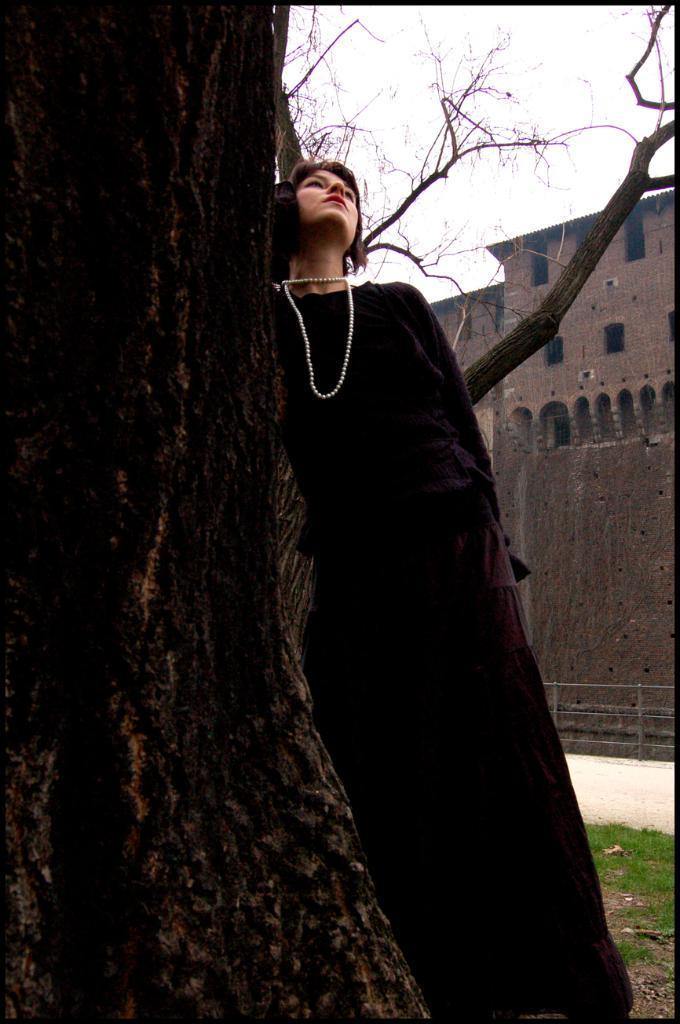Please provide a concise description of this image. In the foreground of this picture we can see a person wearing black color dress and leaning on the trunk of the tree. In the background we can see the sky, building and the green grass and we can see the branches of the tree. 